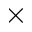Convert formula to latex. <formula><loc_0><loc_0><loc_500><loc_500>\times</formula> 